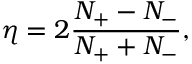<formula> <loc_0><loc_0><loc_500><loc_500>\eta = 2 \frac { N _ { + } - N _ { - } } { N _ { + } + N _ { - } } ,</formula> 